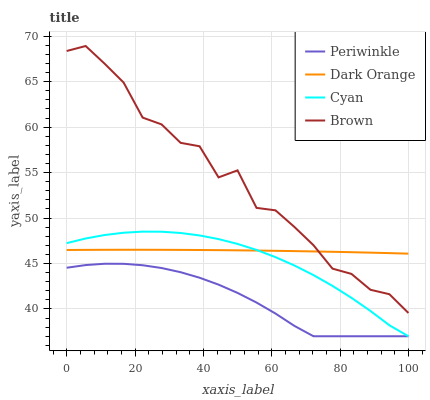Does Periwinkle have the minimum area under the curve?
Answer yes or no. Yes. Does Brown have the maximum area under the curve?
Answer yes or no. Yes. Does Brown have the minimum area under the curve?
Answer yes or no. No. Does Periwinkle have the maximum area under the curve?
Answer yes or no. No. Is Dark Orange the smoothest?
Answer yes or no. Yes. Is Brown the roughest?
Answer yes or no. Yes. Is Periwinkle the smoothest?
Answer yes or no. No. Is Periwinkle the roughest?
Answer yes or no. No. Does Periwinkle have the lowest value?
Answer yes or no. Yes. Does Brown have the lowest value?
Answer yes or no. No. Does Brown have the highest value?
Answer yes or no. Yes. Does Periwinkle have the highest value?
Answer yes or no. No. Is Periwinkle less than Brown?
Answer yes or no. Yes. Is Brown greater than Cyan?
Answer yes or no. Yes. Does Brown intersect Dark Orange?
Answer yes or no. Yes. Is Brown less than Dark Orange?
Answer yes or no. No. Is Brown greater than Dark Orange?
Answer yes or no. No. Does Periwinkle intersect Brown?
Answer yes or no. No. 